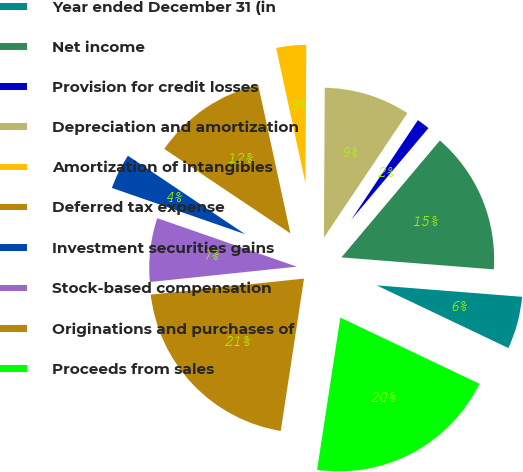Convert chart. <chart><loc_0><loc_0><loc_500><loc_500><pie_chart><fcel>Year ended December 31 (in<fcel>Net income<fcel>Provision for credit losses<fcel>Depreciation and amortization<fcel>Amortization of intangibles<fcel>Deferred tax expense<fcel>Investment securities gains<fcel>Stock-based compensation<fcel>Originations and purchases of<fcel>Proceeds from sales<nl><fcel>5.82%<fcel>15.11%<fcel>1.75%<fcel>9.3%<fcel>3.49%<fcel>12.21%<fcel>4.07%<fcel>6.98%<fcel>20.93%<fcel>20.34%<nl></chart> 